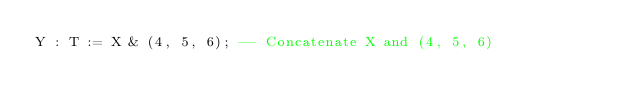<code> <loc_0><loc_0><loc_500><loc_500><_Ada_>Y : T := X & (4, 5, 6); -- Concatenate X and (4, 5, 6)
</code> 